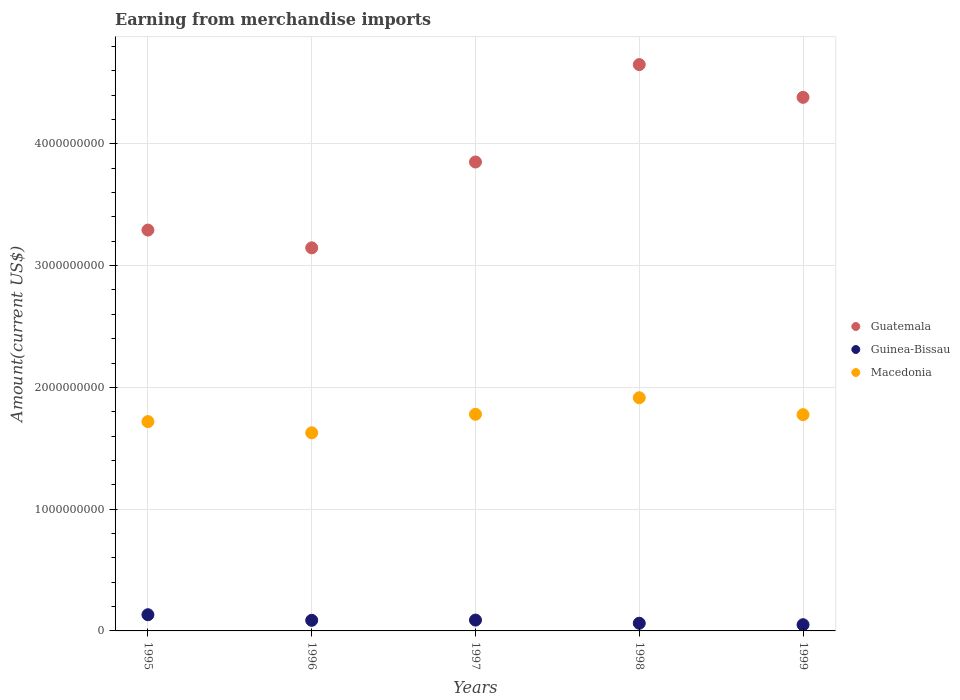How many different coloured dotlines are there?
Provide a short and direct response. 3. Is the number of dotlines equal to the number of legend labels?
Keep it short and to the point. Yes. What is the amount earned from merchandise imports in Macedonia in 1997?
Give a very brief answer. 1.78e+09. Across all years, what is the maximum amount earned from merchandise imports in Guinea-Bissau?
Keep it short and to the point. 1.33e+08. Across all years, what is the minimum amount earned from merchandise imports in Guinea-Bissau?
Provide a succinct answer. 5.10e+07. What is the total amount earned from merchandise imports in Guatemala in the graph?
Your answer should be compact. 1.93e+1. What is the difference between the amount earned from merchandise imports in Guinea-Bissau in 1996 and that in 1998?
Your response must be concise. 2.40e+07. What is the difference between the amount earned from merchandise imports in Macedonia in 1998 and the amount earned from merchandise imports in Guatemala in 1995?
Provide a succinct answer. -1.38e+09. What is the average amount earned from merchandise imports in Guatemala per year?
Provide a short and direct response. 3.86e+09. In the year 1998, what is the difference between the amount earned from merchandise imports in Guatemala and amount earned from merchandise imports in Guinea-Bissau?
Provide a succinct answer. 4.59e+09. In how many years, is the amount earned from merchandise imports in Macedonia greater than 2200000000 US$?
Your response must be concise. 0. What is the ratio of the amount earned from merchandise imports in Macedonia in 1998 to that in 1999?
Keep it short and to the point. 1.08. Is the amount earned from merchandise imports in Macedonia in 1995 less than that in 1996?
Your answer should be compact. No. Is the difference between the amount earned from merchandise imports in Guatemala in 1995 and 1997 greater than the difference between the amount earned from merchandise imports in Guinea-Bissau in 1995 and 1997?
Ensure brevity in your answer.  No. What is the difference between the highest and the second highest amount earned from merchandise imports in Guatemala?
Give a very brief answer. 2.69e+08. What is the difference between the highest and the lowest amount earned from merchandise imports in Macedonia?
Keep it short and to the point. 2.88e+08. Is the sum of the amount earned from merchandise imports in Macedonia in 1995 and 1998 greater than the maximum amount earned from merchandise imports in Guinea-Bissau across all years?
Give a very brief answer. Yes. Is it the case that in every year, the sum of the amount earned from merchandise imports in Guinea-Bissau and amount earned from merchandise imports in Macedonia  is greater than the amount earned from merchandise imports in Guatemala?
Give a very brief answer. No. What is the difference between two consecutive major ticks on the Y-axis?
Offer a very short reply. 1.00e+09. Are the values on the major ticks of Y-axis written in scientific E-notation?
Your answer should be compact. No. Where does the legend appear in the graph?
Provide a short and direct response. Center right. How many legend labels are there?
Give a very brief answer. 3. How are the legend labels stacked?
Keep it short and to the point. Vertical. What is the title of the graph?
Keep it short and to the point. Earning from merchandise imports. What is the label or title of the Y-axis?
Give a very brief answer. Amount(current US$). What is the Amount(current US$) of Guatemala in 1995?
Your answer should be compact. 3.29e+09. What is the Amount(current US$) of Guinea-Bissau in 1995?
Offer a terse response. 1.33e+08. What is the Amount(current US$) of Macedonia in 1995?
Provide a short and direct response. 1.72e+09. What is the Amount(current US$) in Guatemala in 1996?
Your answer should be compact. 3.15e+09. What is the Amount(current US$) in Guinea-Bissau in 1996?
Make the answer very short. 8.70e+07. What is the Amount(current US$) of Macedonia in 1996?
Offer a very short reply. 1.63e+09. What is the Amount(current US$) in Guatemala in 1997?
Ensure brevity in your answer.  3.85e+09. What is the Amount(current US$) of Guinea-Bissau in 1997?
Offer a very short reply. 8.90e+07. What is the Amount(current US$) in Macedonia in 1997?
Your response must be concise. 1.78e+09. What is the Amount(current US$) in Guatemala in 1998?
Ensure brevity in your answer.  4.65e+09. What is the Amount(current US$) in Guinea-Bissau in 1998?
Give a very brief answer. 6.30e+07. What is the Amount(current US$) of Macedonia in 1998?
Give a very brief answer. 1.92e+09. What is the Amount(current US$) of Guatemala in 1999?
Offer a terse response. 4.38e+09. What is the Amount(current US$) of Guinea-Bissau in 1999?
Provide a succinct answer. 5.10e+07. What is the Amount(current US$) of Macedonia in 1999?
Keep it short and to the point. 1.78e+09. Across all years, what is the maximum Amount(current US$) in Guatemala?
Your response must be concise. 4.65e+09. Across all years, what is the maximum Amount(current US$) of Guinea-Bissau?
Offer a terse response. 1.33e+08. Across all years, what is the maximum Amount(current US$) of Macedonia?
Ensure brevity in your answer.  1.92e+09. Across all years, what is the minimum Amount(current US$) in Guatemala?
Your answer should be compact. 3.15e+09. Across all years, what is the minimum Amount(current US$) in Guinea-Bissau?
Provide a short and direct response. 5.10e+07. Across all years, what is the minimum Amount(current US$) in Macedonia?
Your answer should be compact. 1.63e+09. What is the total Amount(current US$) in Guatemala in the graph?
Your response must be concise. 1.93e+1. What is the total Amount(current US$) in Guinea-Bissau in the graph?
Offer a terse response. 4.23e+08. What is the total Amount(current US$) of Macedonia in the graph?
Your response must be concise. 8.82e+09. What is the difference between the Amount(current US$) in Guatemala in 1995 and that in 1996?
Give a very brief answer. 1.46e+08. What is the difference between the Amount(current US$) of Guinea-Bissau in 1995 and that in 1996?
Provide a succinct answer. 4.60e+07. What is the difference between the Amount(current US$) of Macedonia in 1995 and that in 1996?
Keep it short and to the point. 9.20e+07. What is the difference between the Amount(current US$) in Guatemala in 1995 and that in 1997?
Give a very brief answer. -5.59e+08. What is the difference between the Amount(current US$) in Guinea-Bissau in 1995 and that in 1997?
Provide a short and direct response. 4.40e+07. What is the difference between the Amount(current US$) of Macedonia in 1995 and that in 1997?
Your answer should be compact. -6.00e+07. What is the difference between the Amount(current US$) of Guatemala in 1995 and that in 1998?
Provide a short and direct response. -1.36e+09. What is the difference between the Amount(current US$) in Guinea-Bissau in 1995 and that in 1998?
Ensure brevity in your answer.  7.00e+07. What is the difference between the Amount(current US$) in Macedonia in 1995 and that in 1998?
Ensure brevity in your answer.  -1.96e+08. What is the difference between the Amount(current US$) in Guatemala in 1995 and that in 1999?
Your response must be concise. -1.09e+09. What is the difference between the Amount(current US$) in Guinea-Bissau in 1995 and that in 1999?
Keep it short and to the point. 8.20e+07. What is the difference between the Amount(current US$) of Macedonia in 1995 and that in 1999?
Offer a terse response. -5.70e+07. What is the difference between the Amount(current US$) of Guatemala in 1996 and that in 1997?
Provide a short and direct response. -7.05e+08. What is the difference between the Amount(current US$) of Macedonia in 1996 and that in 1997?
Ensure brevity in your answer.  -1.52e+08. What is the difference between the Amount(current US$) of Guatemala in 1996 and that in 1998?
Provide a short and direct response. -1.50e+09. What is the difference between the Amount(current US$) of Guinea-Bissau in 1996 and that in 1998?
Make the answer very short. 2.40e+07. What is the difference between the Amount(current US$) in Macedonia in 1996 and that in 1998?
Your response must be concise. -2.88e+08. What is the difference between the Amount(current US$) in Guatemala in 1996 and that in 1999?
Provide a succinct answer. -1.24e+09. What is the difference between the Amount(current US$) of Guinea-Bissau in 1996 and that in 1999?
Provide a short and direct response. 3.60e+07. What is the difference between the Amount(current US$) in Macedonia in 1996 and that in 1999?
Offer a very short reply. -1.49e+08. What is the difference between the Amount(current US$) of Guatemala in 1997 and that in 1998?
Offer a terse response. -8.00e+08. What is the difference between the Amount(current US$) of Guinea-Bissau in 1997 and that in 1998?
Offer a very short reply. 2.60e+07. What is the difference between the Amount(current US$) of Macedonia in 1997 and that in 1998?
Provide a short and direct response. -1.36e+08. What is the difference between the Amount(current US$) of Guatemala in 1997 and that in 1999?
Ensure brevity in your answer.  -5.31e+08. What is the difference between the Amount(current US$) in Guinea-Bissau in 1997 and that in 1999?
Keep it short and to the point. 3.80e+07. What is the difference between the Amount(current US$) of Guatemala in 1998 and that in 1999?
Your response must be concise. 2.69e+08. What is the difference between the Amount(current US$) in Guinea-Bissau in 1998 and that in 1999?
Offer a very short reply. 1.20e+07. What is the difference between the Amount(current US$) of Macedonia in 1998 and that in 1999?
Provide a succinct answer. 1.39e+08. What is the difference between the Amount(current US$) in Guatemala in 1995 and the Amount(current US$) in Guinea-Bissau in 1996?
Your response must be concise. 3.20e+09. What is the difference between the Amount(current US$) in Guatemala in 1995 and the Amount(current US$) in Macedonia in 1996?
Offer a terse response. 1.66e+09. What is the difference between the Amount(current US$) of Guinea-Bissau in 1995 and the Amount(current US$) of Macedonia in 1996?
Keep it short and to the point. -1.49e+09. What is the difference between the Amount(current US$) in Guatemala in 1995 and the Amount(current US$) in Guinea-Bissau in 1997?
Make the answer very short. 3.20e+09. What is the difference between the Amount(current US$) in Guatemala in 1995 and the Amount(current US$) in Macedonia in 1997?
Offer a very short reply. 1.51e+09. What is the difference between the Amount(current US$) of Guinea-Bissau in 1995 and the Amount(current US$) of Macedonia in 1997?
Offer a very short reply. -1.65e+09. What is the difference between the Amount(current US$) in Guatemala in 1995 and the Amount(current US$) in Guinea-Bissau in 1998?
Keep it short and to the point. 3.23e+09. What is the difference between the Amount(current US$) of Guatemala in 1995 and the Amount(current US$) of Macedonia in 1998?
Your response must be concise. 1.38e+09. What is the difference between the Amount(current US$) of Guinea-Bissau in 1995 and the Amount(current US$) of Macedonia in 1998?
Offer a very short reply. -1.78e+09. What is the difference between the Amount(current US$) in Guatemala in 1995 and the Amount(current US$) in Guinea-Bissau in 1999?
Provide a succinct answer. 3.24e+09. What is the difference between the Amount(current US$) in Guatemala in 1995 and the Amount(current US$) in Macedonia in 1999?
Offer a very short reply. 1.52e+09. What is the difference between the Amount(current US$) in Guinea-Bissau in 1995 and the Amount(current US$) in Macedonia in 1999?
Ensure brevity in your answer.  -1.64e+09. What is the difference between the Amount(current US$) of Guatemala in 1996 and the Amount(current US$) of Guinea-Bissau in 1997?
Offer a very short reply. 3.06e+09. What is the difference between the Amount(current US$) of Guatemala in 1996 and the Amount(current US$) of Macedonia in 1997?
Your response must be concise. 1.37e+09. What is the difference between the Amount(current US$) of Guinea-Bissau in 1996 and the Amount(current US$) of Macedonia in 1997?
Make the answer very short. -1.69e+09. What is the difference between the Amount(current US$) of Guatemala in 1996 and the Amount(current US$) of Guinea-Bissau in 1998?
Give a very brief answer. 3.08e+09. What is the difference between the Amount(current US$) of Guatemala in 1996 and the Amount(current US$) of Macedonia in 1998?
Ensure brevity in your answer.  1.23e+09. What is the difference between the Amount(current US$) of Guinea-Bissau in 1996 and the Amount(current US$) of Macedonia in 1998?
Give a very brief answer. -1.83e+09. What is the difference between the Amount(current US$) of Guatemala in 1996 and the Amount(current US$) of Guinea-Bissau in 1999?
Your response must be concise. 3.10e+09. What is the difference between the Amount(current US$) in Guatemala in 1996 and the Amount(current US$) in Macedonia in 1999?
Provide a succinct answer. 1.37e+09. What is the difference between the Amount(current US$) of Guinea-Bissau in 1996 and the Amount(current US$) of Macedonia in 1999?
Ensure brevity in your answer.  -1.69e+09. What is the difference between the Amount(current US$) in Guatemala in 1997 and the Amount(current US$) in Guinea-Bissau in 1998?
Give a very brief answer. 3.79e+09. What is the difference between the Amount(current US$) of Guatemala in 1997 and the Amount(current US$) of Macedonia in 1998?
Offer a terse response. 1.94e+09. What is the difference between the Amount(current US$) of Guinea-Bissau in 1997 and the Amount(current US$) of Macedonia in 1998?
Provide a short and direct response. -1.83e+09. What is the difference between the Amount(current US$) in Guatemala in 1997 and the Amount(current US$) in Guinea-Bissau in 1999?
Provide a short and direct response. 3.80e+09. What is the difference between the Amount(current US$) of Guatemala in 1997 and the Amount(current US$) of Macedonia in 1999?
Your answer should be compact. 2.08e+09. What is the difference between the Amount(current US$) of Guinea-Bissau in 1997 and the Amount(current US$) of Macedonia in 1999?
Give a very brief answer. -1.69e+09. What is the difference between the Amount(current US$) in Guatemala in 1998 and the Amount(current US$) in Guinea-Bissau in 1999?
Ensure brevity in your answer.  4.60e+09. What is the difference between the Amount(current US$) in Guatemala in 1998 and the Amount(current US$) in Macedonia in 1999?
Ensure brevity in your answer.  2.88e+09. What is the difference between the Amount(current US$) of Guinea-Bissau in 1998 and the Amount(current US$) of Macedonia in 1999?
Your response must be concise. -1.71e+09. What is the average Amount(current US$) in Guatemala per year?
Give a very brief answer. 3.86e+09. What is the average Amount(current US$) of Guinea-Bissau per year?
Keep it short and to the point. 8.46e+07. What is the average Amount(current US$) of Macedonia per year?
Give a very brief answer. 1.76e+09. In the year 1995, what is the difference between the Amount(current US$) of Guatemala and Amount(current US$) of Guinea-Bissau?
Your answer should be very brief. 3.16e+09. In the year 1995, what is the difference between the Amount(current US$) of Guatemala and Amount(current US$) of Macedonia?
Offer a terse response. 1.57e+09. In the year 1995, what is the difference between the Amount(current US$) in Guinea-Bissau and Amount(current US$) in Macedonia?
Your answer should be compact. -1.59e+09. In the year 1996, what is the difference between the Amount(current US$) in Guatemala and Amount(current US$) in Guinea-Bissau?
Your answer should be very brief. 3.06e+09. In the year 1996, what is the difference between the Amount(current US$) in Guatemala and Amount(current US$) in Macedonia?
Provide a short and direct response. 1.52e+09. In the year 1996, what is the difference between the Amount(current US$) of Guinea-Bissau and Amount(current US$) of Macedonia?
Offer a very short reply. -1.54e+09. In the year 1997, what is the difference between the Amount(current US$) in Guatemala and Amount(current US$) in Guinea-Bissau?
Offer a terse response. 3.76e+09. In the year 1997, what is the difference between the Amount(current US$) in Guatemala and Amount(current US$) in Macedonia?
Your response must be concise. 2.07e+09. In the year 1997, what is the difference between the Amount(current US$) of Guinea-Bissau and Amount(current US$) of Macedonia?
Provide a succinct answer. -1.69e+09. In the year 1998, what is the difference between the Amount(current US$) of Guatemala and Amount(current US$) of Guinea-Bissau?
Give a very brief answer. 4.59e+09. In the year 1998, what is the difference between the Amount(current US$) of Guatemala and Amount(current US$) of Macedonia?
Give a very brief answer. 2.74e+09. In the year 1998, what is the difference between the Amount(current US$) of Guinea-Bissau and Amount(current US$) of Macedonia?
Offer a very short reply. -1.85e+09. In the year 1999, what is the difference between the Amount(current US$) of Guatemala and Amount(current US$) of Guinea-Bissau?
Give a very brief answer. 4.33e+09. In the year 1999, what is the difference between the Amount(current US$) of Guatemala and Amount(current US$) of Macedonia?
Keep it short and to the point. 2.61e+09. In the year 1999, what is the difference between the Amount(current US$) in Guinea-Bissau and Amount(current US$) in Macedonia?
Provide a succinct answer. -1.72e+09. What is the ratio of the Amount(current US$) of Guatemala in 1995 to that in 1996?
Your answer should be compact. 1.05. What is the ratio of the Amount(current US$) in Guinea-Bissau in 1995 to that in 1996?
Your response must be concise. 1.53. What is the ratio of the Amount(current US$) of Macedonia in 1995 to that in 1996?
Provide a short and direct response. 1.06. What is the ratio of the Amount(current US$) of Guatemala in 1995 to that in 1997?
Ensure brevity in your answer.  0.85. What is the ratio of the Amount(current US$) in Guinea-Bissau in 1995 to that in 1997?
Offer a very short reply. 1.49. What is the ratio of the Amount(current US$) in Macedonia in 1995 to that in 1997?
Your answer should be compact. 0.97. What is the ratio of the Amount(current US$) in Guatemala in 1995 to that in 1998?
Your answer should be compact. 0.71. What is the ratio of the Amount(current US$) of Guinea-Bissau in 1995 to that in 1998?
Your answer should be compact. 2.11. What is the ratio of the Amount(current US$) in Macedonia in 1995 to that in 1998?
Offer a very short reply. 0.9. What is the ratio of the Amount(current US$) of Guatemala in 1995 to that in 1999?
Your response must be concise. 0.75. What is the ratio of the Amount(current US$) in Guinea-Bissau in 1995 to that in 1999?
Your answer should be very brief. 2.61. What is the ratio of the Amount(current US$) of Macedonia in 1995 to that in 1999?
Keep it short and to the point. 0.97. What is the ratio of the Amount(current US$) of Guatemala in 1996 to that in 1997?
Make the answer very short. 0.82. What is the ratio of the Amount(current US$) of Guinea-Bissau in 1996 to that in 1997?
Ensure brevity in your answer.  0.98. What is the ratio of the Amount(current US$) in Macedonia in 1996 to that in 1997?
Give a very brief answer. 0.91. What is the ratio of the Amount(current US$) of Guatemala in 1996 to that in 1998?
Keep it short and to the point. 0.68. What is the ratio of the Amount(current US$) in Guinea-Bissau in 1996 to that in 1998?
Make the answer very short. 1.38. What is the ratio of the Amount(current US$) in Macedonia in 1996 to that in 1998?
Provide a short and direct response. 0.85. What is the ratio of the Amount(current US$) of Guatemala in 1996 to that in 1999?
Offer a very short reply. 0.72. What is the ratio of the Amount(current US$) of Guinea-Bissau in 1996 to that in 1999?
Make the answer very short. 1.71. What is the ratio of the Amount(current US$) in Macedonia in 1996 to that in 1999?
Offer a very short reply. 0.92. What is the ratio of the Amount(current US$) of Guatemala in 1997 to that in 1998?
Your answer should be very brief. 0.83. What is the ratio of the Amount(current US$) of Guinea-Bissau in 1997 to that in 1998?
Your answer should be very brief. 1.41. What is the ratio of the Amount(current US$) in Macedonia in 1997 to that in 1998?
Offer a terse response. 0.93. What is the ratio of the Amount(current US$) in Guatemala in 1997 to that in 1999?
Provide a succinct answer. 0.88. What is the ratio of the Amount(current US$) of Guinea-Bissau in 1997 to that in 1999?
Provide a succinct answer. 1.75. What is the ratio of the Amount(current US$) in Guatemala in 1998 to that in 1999?
Provide a short and direct response. 1.06. What is the ratio of the Amount(current US$) in Guinea-Bissau in 1998 to that in 1999?
Your answer should be very brief. 1.24. What is the ratio of the Amount(current US$) in Macedonia in 1998 to that in 1999?
Offer a terse response. 1.08. What is the difference between the highest and the second highest Amount(current US$) of Guatemala?
Offer a terse response. 2.69e+08. What is the difference between the highest and the second highest Amount(current US$) of Guinea-Bissau?
Your answer should be compact. 4.40e+07. What is the difference between the highest and the second highest Amount(current US$) in Macedonia?
Your response must be concise. 1.36e+08. What is the difference between the highest and the lowest Amount(current US$) in Guatemala?
Give a very brief answer. 1.50e+09. What is the difference between the highest and the lowest Amount(current US$) of Guinea-Bissau?
Make the answer very short. 8.20e+07. What is the difference between the highest and the lowest Amount(current US$) of Macedonia?
Give a very brief answer. 2.88e+08. 